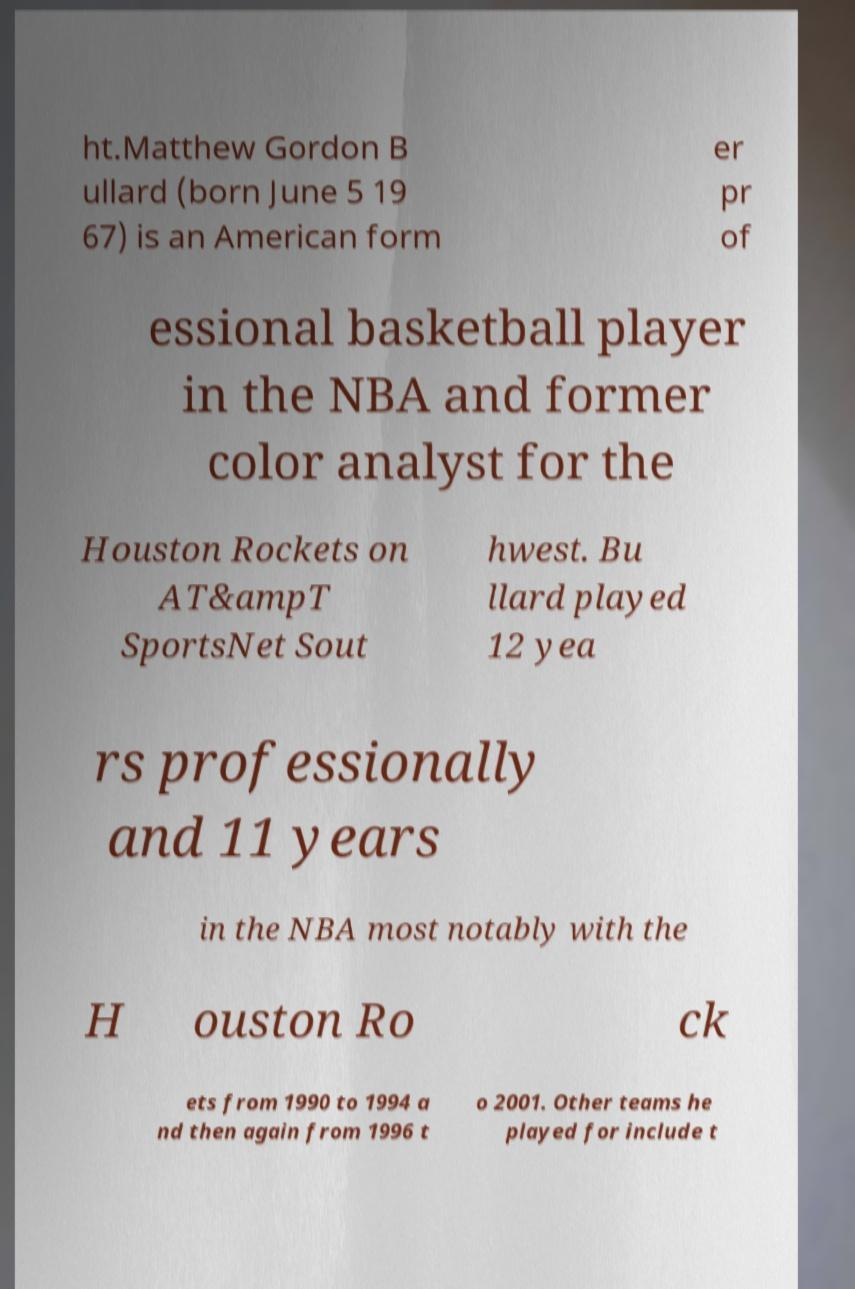Can you accurately transcribe the text from the provided image for me? ht.Matthew Gordon B ullard (born June 5 19 67) is an American form er pr of essional basketball player in the NBA and former color analyst for the Houston Rockets on AT&ampT SportsNet Sout hwest. Bu llard played 12 yea rs professionally and 11 years in the NBA most notably with the H ouston Ro ck ets from 1990 to 1994 a nd then again from 1996 t o 2001. Other teams he played for include t 